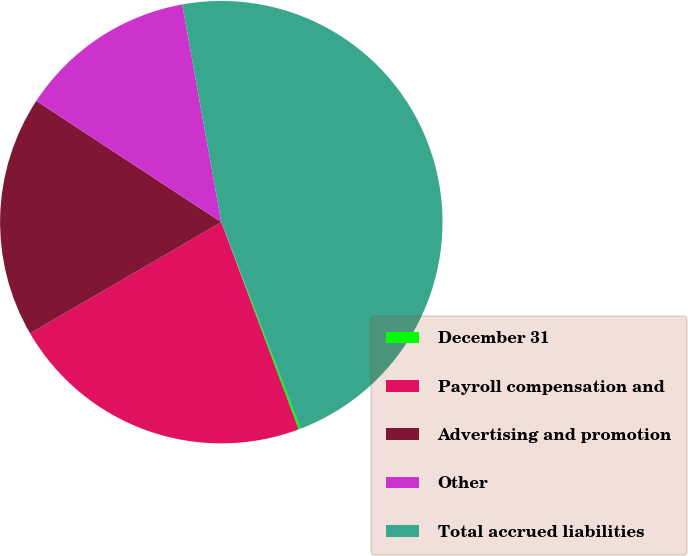<chart> <loc_0><loc_0><loc_500><loc_500><pie_chart><fcel>December 31<fcel>Payroll compensation and<fcel>Advertising and promotion<fcel>Other<fcel>Total accrued liabilities<nl><fcel>0.16%<fcel>22.3%<fcel>17.62%<fcel>12.94%<fcel>46.98%<nl></chart> 